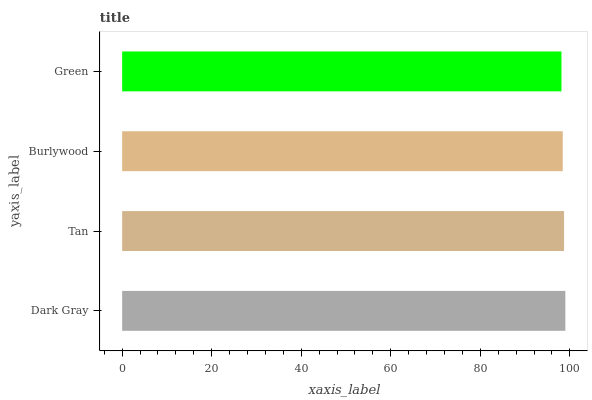Is Green the minimum?
Answer yes or no. Yes. Is Dark Gray the maximum?
Answer yes or no. Yes. Is Tan the minimum?
Answer yes or no. No. Is Tan the maximum?
Answer yes or no. No. Is Dark Gray greater than Tan?
Answer yes or no. Yes. Is Tan less than Dark Gray?
Answer yes or no. Yes. Is Tan greater than Dark Gray?
Answer yes or no. No. Is Dark Gray less than Tan?
Answer yes or no. No. Is Tan the high median?
Answer yes or no. Yes. Is Burlywood the low median?
Answer yes or no. Yes. Is Burlywood the high median?
Answer yes or no. No. Is Green the low median?
Answer yes or no. No. 